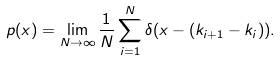Convert formula to latex. <formula><loc_0><loc_0><loc_500><loc_500>p ( x ) = \lim _ { N \to \infty } \frac { 1 } { N } \sum _ { i = 1 } ^ { N } \delta ( x - ( k _ { i + 1 } - k _ { i } ) ) .</formula> 